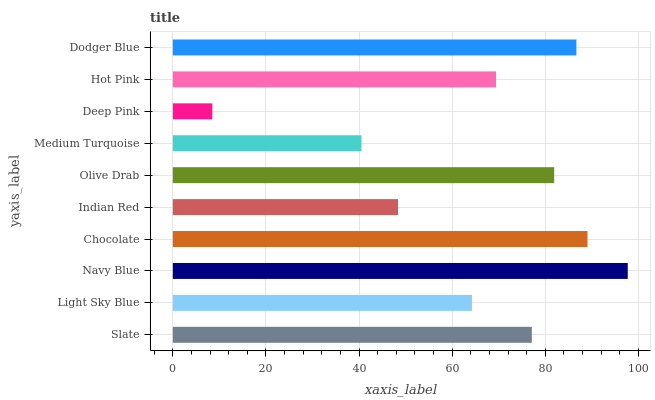Is Deep Pink the minimum?
Answer yes or no. Yes. Is Navy Blue the maximum?
Answer yes or no. Yes. Is Light Sky Blue the minimum?
Answer yes or no. No. Is Light Sky Blue the maximum?
Answer yes or no. No. Is Slate greater than Light Sky Blue?
Answer yes or no. Yes. Is Light Sky Blue less than Slate?
Answer yes or no. Yes. Is Light Sky Blue greater than Slate?
Answer yes or no. No. Is Slate less than Light Sky Blue?
Answer yes or no. No. Is Slate the high median?
Answer yes or no. Yes. Is Hot Pink the low median?
Answer yes or no. Yes. Is Chocolate the high median?
Answer yes or no. No. Is Deep Pink the low median?
Answer yes or no. No. 